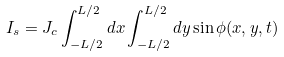<formula> <loc_0><loc_0><loc_500><loc_500>I _ { s } = J _ { c } \int _ { - L / 2 } ^ { L / 2 } d x \int _ { - L / 2 } ^ { L / 2 } d y \sin \phi ( x , y , t )</formula> 